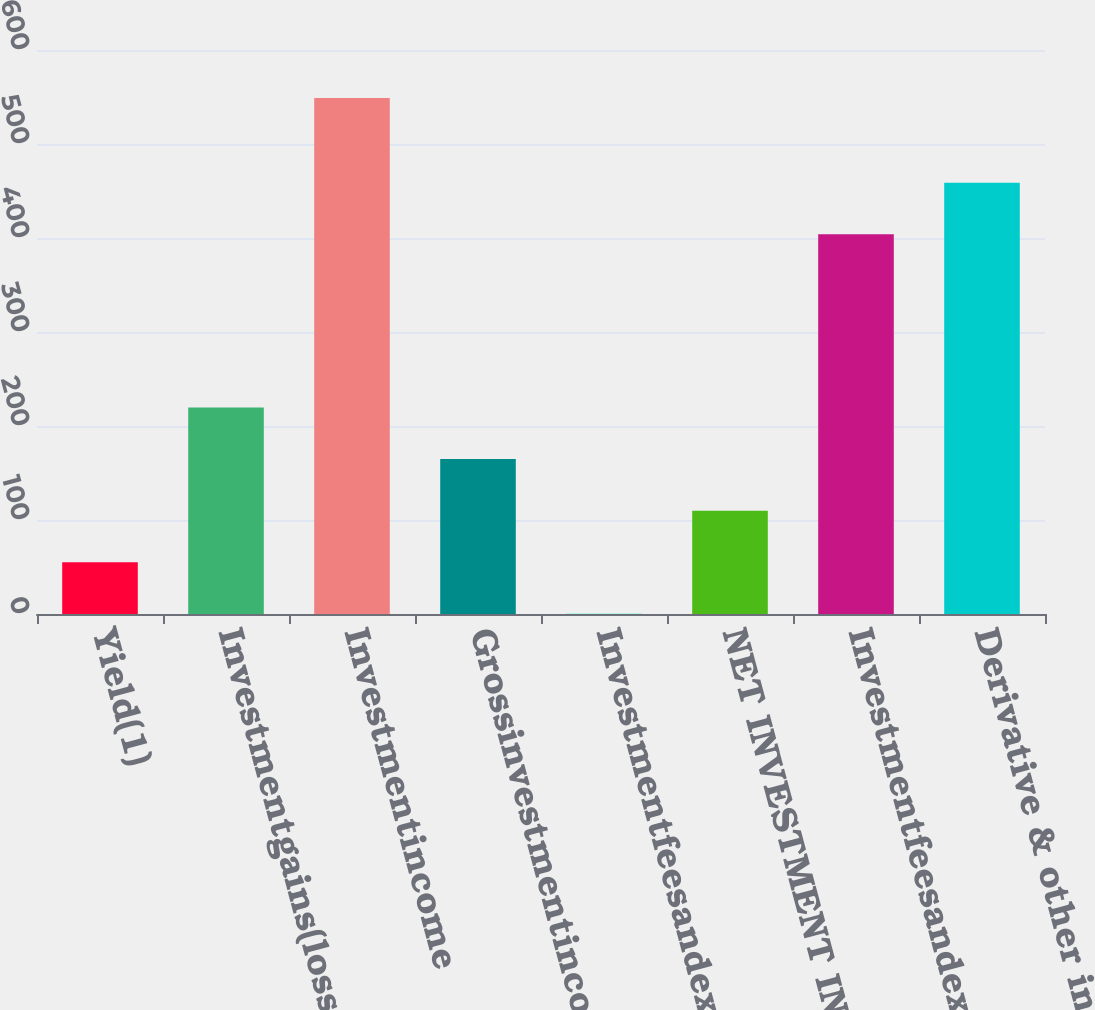<chart> <loc_0><loc_0><loc_500><loc_500><bar_chart><fcel>Yield(1)<fcel>Investmentgains(losses)<fcel>Investmentincome<fcel>Grossinvestmentincomeyield(1)<fcel>Investmentfeesandexpensesyield<fcel>NET INVESTMENT INCOME YIELD<fcel>Investmentfeesandexpenses<fcel>Derivative & other instruments<nl><fcel>55.04<fcel>219.69<fcel>549<fcel>164.81<fcel>0.15<fcel>109.93<fcel>404<fcel>458.88<nl></chart> 